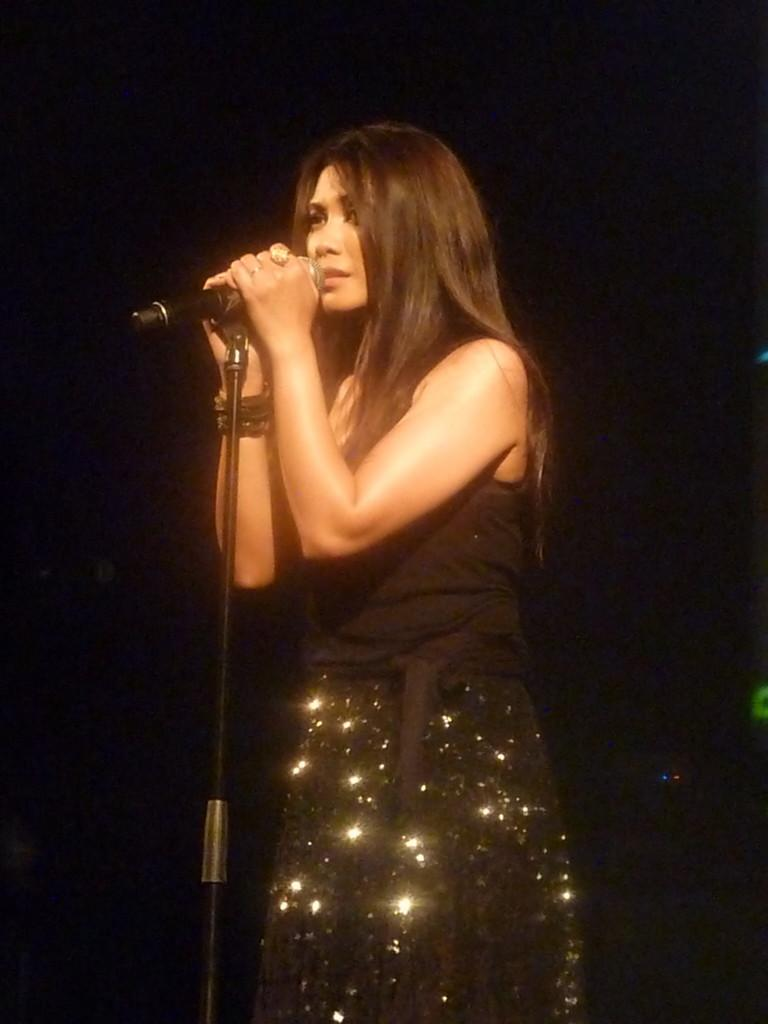Who is the main subject in the image? There is a woman in the image. What is the woman doing in the image? The woman is standing and holding a microphone. What else can be seen in the image besides the woman? There is a stand in the image. How would you describe the background of the image? The background of the image is dark. What type of smell can be detected in the image? There is no information about smells in the image, so it cannot be determined. 